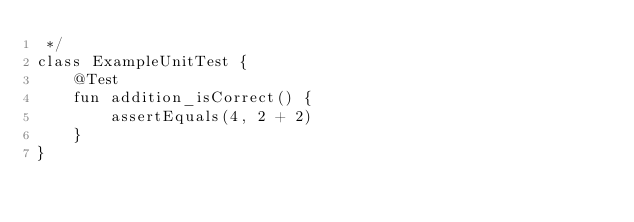<code> <loc_0><loc_0><loc_500><loc_500><_Kotlin_> */
class ExampleUnitTest {
    @Test
    fun addition_isCorrect() {
        assertEquals(4, 2 + 2)
    }
}
</code> 